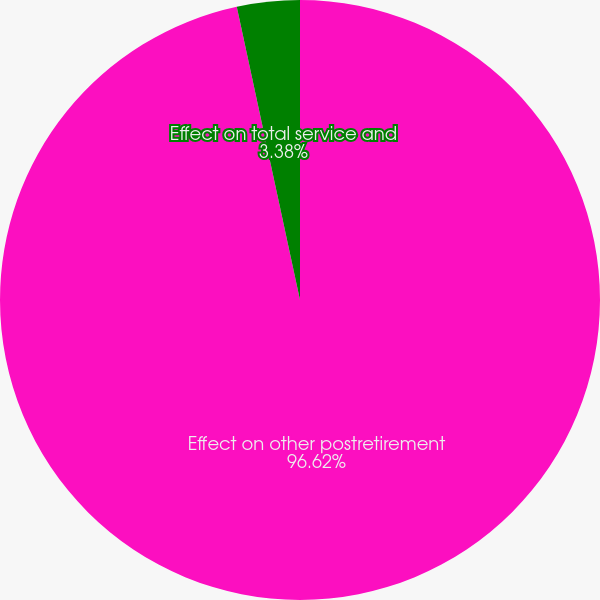Convert chart. <chart><loc_0><loc_0><loc_500><loc_500><pie_chart><fcel>Effect on other postretirement<fcel>Effect on total service and<nl><fcel>96.62%<fcel>3.38%<nl></chart> 